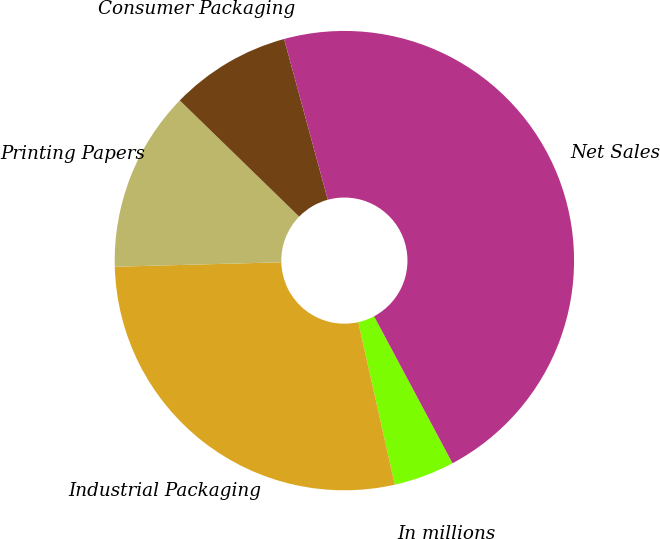Convert chart. <chart><loc_0><loc_0><loc_500><loc_500><pie_chart><fcel>In millions<fcel>Industrial Packaging<fcel>Printing Papers<fcel>Consumer Packaging<fcel>Net Sales<nl><fcel>4.28%<fcel>28.1%<fcel>12.71%<fcel>8.49%<fcel>46.43%<nl></chart> 